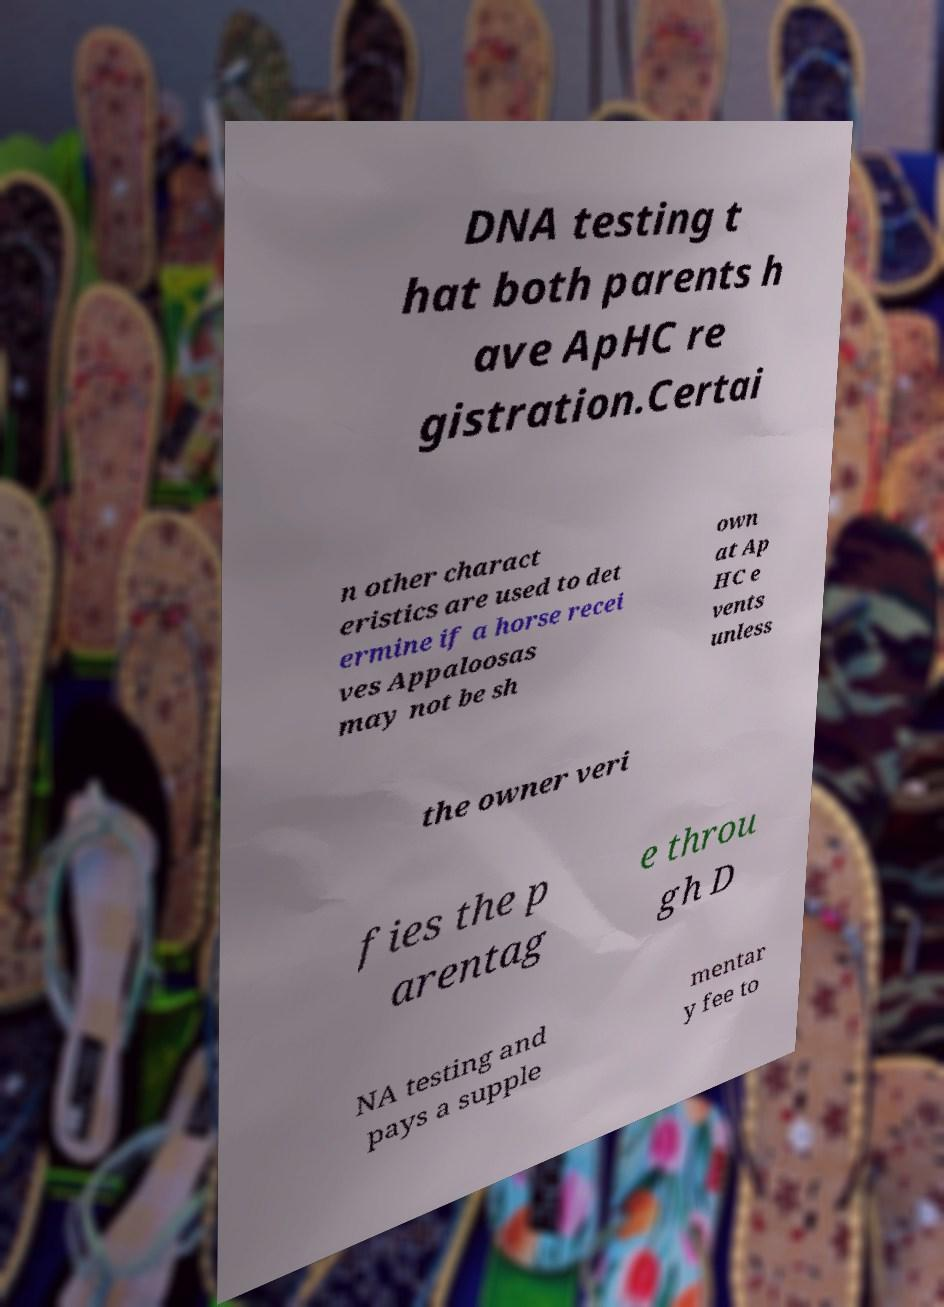I need the written content from this picture converted into text. Can you do that? DNA testing t hat both parents h ave ApHC re gistration.Certai n other charact eristics are used to det ermine if a horse recei ves Appaloosas may not be sh own at Ap HC e vents unless the owner veri fies the p arentag e throu gh D NA testing and pays a supple mentar y fee to 